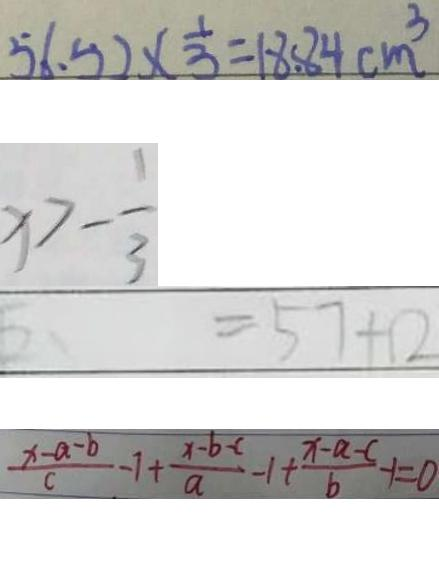<formula> <loc_0><loc_0><loc_500><loc_500>5 6 . 5 2 \times \frac { 1 } { 3 } = 1 8 . 8 4 c m ^ { 3 } 
 x > - \frac { 1 } { 3 } 
 = 5 7 + 1 2 
 \frac { x - a - b } { c } - 1 + \frac { x - b - c } { a } - 1 + \frac { x - a - c } { b } - 1 = 0</formula> 